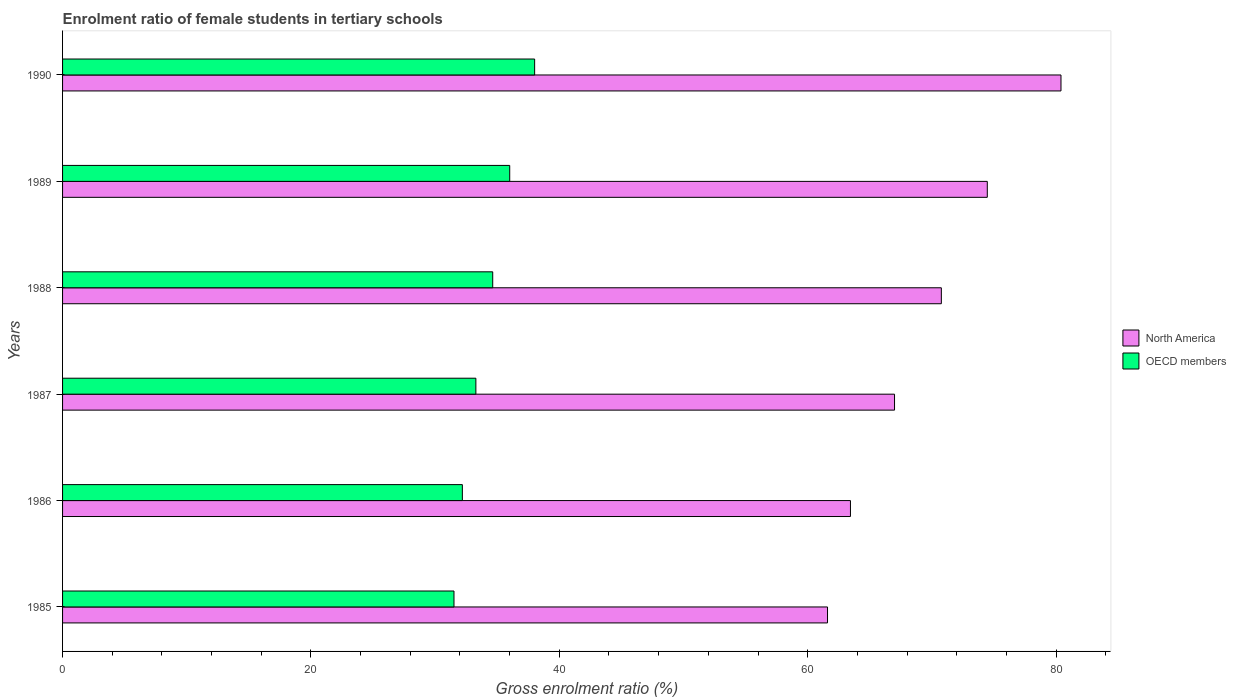How many groups of bars are there?
Your response must be concise. 6. Are the number of bars per tick equal to the number of legend labels?
Ensure brevity in your answer.  Yes. Are the number of bars on each tick of the Y-axis equal?
Offer a very short reply. Yes. How many bars are there on the 1st tick from the top?
Give a very brief answer. 2. How many bars are there on the 2nd tick from the bottom?
Keep it short and to the point. 2. In how many cases, is the number of bars for a given year not equal to the number of legend labels?
Provide a succinct answer. 0. What is the enrolment ratio of female students in tertiary schools in OECD members in 1990?
Ensure brevity in your answer.  38.01. Across all years, what is the maximum enrolment ratio of female students in tertiary schools in North America?
Provide a short and direct response. 80.4. Across all years, what is the minimum enrolment ratio of female students in tertiary schools in OECD members?
Your answer should be very brief. 31.52. In which year was the enrolment ratio of female students in tertiary schools in OECD members maximum?
Make the answer very short. 1990. In which year was the enrolment ratio of female students in tertiary schools in North America minimum?
Offer a terse response. 1985. What is the total enrolment ratio of female students in tertiary schools in North America in the graph?
Give a very brief answer. 417.66. What is the difference between the enrolment ratio of female students in tertiary schools in North America in 1988 and that in 1990?
Your answer should be compact. -9.63. What is the difference between the enrolment ratio of female students in tertiary schools in OECD members in 1990 and the enrolment ratio of female students in tertiary schools in North America in 1988?
Provide a succinct answer. -32.75. What is the average enrolment ratio of female students in tertiary schools in OECD members per year?
Make the answer very short. 34.28. In the year 1987, what is the difference between the enrolment ratio of female students in tertiary schools in OECD members and enrolment ratio of female students in tertiary schools in North America?
Offer a terse response. -33.71. What is the ratio of the enrolment ratio of female students in tertiary schools in North America in 1986 to that in 1988?
Keep it short and to the point. 0.9. Is the difference between the enrolment ratio of female students in tertiary schools in OECD members in 1985 and 1986 greater than the difference between the enrolment ratio of female students in tertiary schools in North America in 1985 and 1986?
Your answer should be compact. Yes. What is the difference between the highest and the second highest enrolment ratio of female students in tertiary schools in North America?
Offer a terse response. 5.93. What is the difference between the highest and the lowest enrolment ratio of female students in tertiary schools in North America?
Offer a terse response. 18.8. Is the sum of the enrolment ratio of female students in tertiary schools in North America in 1985 and 1990 greater than the maximum enrolment ratio of female students in tertiary schools in OECD members across all years?
Keep it short and to the point. Yes. How many bars are there?
Your response must be concise. 12. Are all the bars in the graph horizontal?
Your answer should be very brief. Yes. What is the difference between two consecutive major ticks on the X-axis?
Your answer should be very brief. 20. Are the values on the major ticks of X-axis written in scientific E-notation?
Offer a terse response. No. Does the graph contain any zero values?
Give a very brief answer. No. How many legend labels are there?
Keep it short and to the point. 2. What is the title of the graph?
Offer a terse response. Enrolment ratio of female students in tertiary schools. Does "French Polynesia" appear as one of the legend labels in the graph?
Give a very brief answer. No. What is the label or title of the Y-axis?
Your answer should be very brief. Years. What is the Gross enrolment ratio (%) of North America in 1985?
Your answer should be compact. 61.6. What is the Gross enrolment ratio (%) in OECD members in 1985?
Keep it short and to the point. 31.52. What is the Gross enrolment ratio (%) of North America in 1986?
Give a very brief answer. 63.44. What is the Gross enrolment ratio (%) in OECD members in 1986?
Make the answer very short. 32.19. What is the Gross enrolment ratio (%) in North America in 1987?
Give a very brief answer. 67. What is the Gross enrolment ratio (%) in OECD members in 1987?
Your answer should be compact. 33.28. What is the Gross enrolment ratio (%) of North America in 1988?
Your answer should be compact. 70.76. What is the Gross enrolment ratio (%) of OECD members in 1988?
Your answer should be very brief. 34.64. What is the Gross enrolment ratio (%) of North America in 1989?
Provide a short and direct response. 74.46. What is the Gross enrolment ratio (%) in OECD members in 1989?
Ensure brevity in your answer.  36.01. What is the Gross enrolment ratio (%) of North America in 1990?
Keep it short and to the point. 80.4. What is the Gross enrolment ratio (%) of OECD members in 1990?
Make the answer very short. 38.01. Across all years, what is the maximum Gross enrolment ratio (%) in North America?
Make the answer very short. 80.4. Across all years, what is the maximum Gross enrolment ratio (%) in OECD members?
Your response must be concise. 38.01. Across all years, what is the minimum Gross enrolment ratio (%) in North America?
Your answer should be compact. 61.6. Across all years, what is the minimum Gross enrolment ratio (%) in OECD members?
Make the answer very short. 31.52. What is the total Gross enrolment ratio (%) in North America in the graph?
Provide a short and direct response. 417.66. What is the total Gross enrolment ratio (%) of OECD members in the graph?
Provide a succinct answer. 205.65. What is the difference between the Gross enrolment ratio (%) of North America in 1985 and that in 1986?
Offer a terse response. -1.85. What is the difference between the Gross enrolment ratio (%) in OECD members in 1985 and that in 1986?
Offer a terse response. -0.67. What is the difference between the Gross enrolment ratio (%) in North America in 1985 and that in 1987?
Offer a very short reply. -5.4. What is the difference between the Gross enrolment ratio (%) of OECD members in 1985 and that in 1987?
Your response must be concise. -1.76. What is the difference between the Gross enrolment ratio (%) of North America in 1985 and that in 1988?
Offer a terse response. -9.17. What is the difference between the Gross enrolment ratio (%) of OECD members in 1985 and that in 1988?
Offer a terse response. -3.12. What is the difference between the Gross enrolment ratio (%) of North America in 1985 and that in 1989?
Give a very brief answer. -12.87. What is the difference between the Gross enrolment ratio (%) of OECD members in 1985 and that in 1989?
Keep it short and to the point. -4.49. What is the difference between the Gross enrolment ratio (%) of North America in 1985 and that in 1990?
Ensure brevity in your answer.  -18.8. What is the difference between the Gross enrolment ratio (%) of OECD members in 1985 and that in 1990?
Offer a terse response. -6.49. What is the difference between the Gross enrolment ratio (%) in North America in 1986 and that in 1987?
Make the answer very short. -3.55. What is the difference between the Gross enrolment ratio (%) in OECD members in 1986 and that in 1987?
Your answer should be very brief. -1.09. What is the difference between the Gross enrolment ratio (%) of North America in 1986 and that in 1988?
Keep it short and to the point. -7.32. What is the difference between the Gross enrolment ratio (%) in OECD members in 1986 and that in 1988?
Keep it short and to the point. -2.44. What is the difference between the Gross enrolment ratio (%) in North America in 1986 and that in 1989?
Your answer should be compact. -11.02. What is the difference between the Gross enrolment ratio (%) in OECD members in 1986 and that in 1989?
Ensure brevity in your answer.  -3.81. What is the difference between the Gross enrolment ratio (%) of North America in 1986 and that in 1990?
Ensure brevity in your answer.  -16.95. What is the difference between the Gross enrolment ratio (%) in OECD members in 1986 and that in 1990?
Make the answer very short. -5.82. What is the difference between the Gross enrolment ratio (%) of North America in 1987 and that in 1988?
Keep it short and to the point. -3.77. What is the difference between the Gross enrolment ratio (%) of OECD members in 1987 and that in 1988?
Provide a short and direct response. -1.36. What is the difference between the Gross enrolment ratio (%) in North America in 1987 and that in 1989?
Your answer should be very brief. -7.47. What is the difference between the Gross enrolment ratio (%) of OECD members in 1987 and that in 1989?
Your answer should be compact. -2.73. What is the difference between the Gross enrolment ratio (%) of North America in 1987 and that in 1990?
Your answer should be very brief. -13.4. What is the difference between the Gross enrolment ratio (%) in OECD members in 1987 and that in 1990?
Give a very brief answer. -4.73. What is the difference between the Gross enrolment ratio (%) in North America in 1988 and that in 1989?
Make the answer very short. -3.7. What is the difference between the Gross enrolment ratio (%) of OECD members in 1988 and that in 1989?
Make the answer very short. -1.37. What is the difference between the Gross enrolment ratio (%) in North America in 1988 and that in 1990?
Your answer should be very brief. -9.63. What is the difference between the Gross enrolment ratio (%) of OECD members in 1988 and that in 1990?
Make the answer very short. -3.38. What is the difference between the Gross enrolment ratio (%) of North America in 1989 and that in 1990?
Offer a terse response. -5.93. What is the difference between the Gross enrolment ratio (%) in OECD members in 1989 and that in 1990?
Provide a short and direct response. -2.01. What is the difference between the Gross enrolment ratio (%) of North America in 1985 and the Gross enrolment ratio (%) of OECD members in 1986?
Your answer should be compact. 29.4. What is the difference between the Gross enrolment ratio (%) of North America in 1985 and the Gross enrolment ratio (%) of OECD members in 1987?
Make the answer very short. 28.32. What is the difference between the Gross enrolment ratio (%) in North America in 1985 and the Gross enrolment ratio (%) in OECD members in 1988?
Your response must be concise. 26.96. What is the difference between the Gross enrolment ratio (%) in North America in 1985 and the Gross enrolment ratio (%) in OECD members in 1989?
Your answer should be compact. 25.59. What is the difference between the Gross enrolment ratio (%) of North America in 1985 and the Gross enrolment ratio (%) of OECD members in 1990?
Provide a short and direct response. 23.58. What is the difference between the Gross enrolment ratio (%) of North America in 1986 and the Gross enrolment ratio (%) of OECD members in 1987?
Provide a short and direct response. 30.16. What is the difference between the Gross enrolment ratio (%) of North America in 1986 and the Gross enrolment ratio (%) of OECD members in 1988?
Your response must be concise. 28.81. What is the difference between the Gross enrolment ratio (%) in North America in 1986 and the Gross enrolment ratio (%) in OECD members in 1989?
Your answer should be compact. 27.44. What is the difference between the Gross enrolment ratio (%) of North America in 1986 and the Gross enrolment ratio (%) of OECD members in 1990?
Offer a very short reply. 25.43. What is the difference between the Gross enrolment ratio (%) of North America in 1987 and the Gross enrolment ratio (%) of OECD members in 1988?
Your answer should be compact. 32.36. What is the difference between the Gross enrolment ratio (%) in North America in 1987 and the Gross enrolment ratio (%) in OECD members in 1989?
Ensure brevity in your answer.  30.99. What is the difference between the Gross enrolment ratio (%) of North America in 1987 and the Gross enrolment ratio (%) of OECD members in 1990?
Provide a succinct answer. 28.98. What is the difference between the Gross enrolment ratio (%) in North America in 1988 and the Gross enrolment ratio (%) in OECD members in 1989?
Ensure brevity in your answer.  34.76. What is the difference between the Gross enrolment ratio (%) of North America in 1988 and the Gross enrolment ratio (%) of OECD members in 1990?
Your response must be concise. 32.75. What is the difference between the Gross enrolment ratio (%) of North America in 1989 and the Gross enrolment ratio (%) of OECD members in 1990?
Your answer should be very brief. 36.45. What is the average Gross enrolment ratio (%) in North America per year?
Offer a terse response. 69.61. What is the average Gross enrolment ratio (%) in OECD members per year?
Provide a succinct answer. 34.28. In the year 1985, what is the difference between the Gross enrolment ratio (%) in North America and Gross enrolment ratio (%) in OECD members?
Your answer should be compact. 30.08. In the year 1986, what is the difference between the Gross enrolment ratio (%) of North America and Gross enrolment ratio (%) of OECD members?
Keep it short and to the point. 31.25. In the year 1987, what is the difference between the Gross enrolment ratio (%) in North America and Gross enrolment ratio (%) in OECD members?
Give a very brief answer. 33.71. In the year 1988, what is the difference between the Gross enrolment ratio (%) of North America and Gross enrolment ratio (%) of OECD members?
Give a very brief answer. 36.13. In the year 1989, what is the difference between the Gross enrolment ratio (%) in North America and Gross enrolment ratio (%) in OECD members?
Your answer should be very brief. 38.46. In the year 1990, what is the difference between the Gross enrolment ratio (%) in North America and Gross enrolment ratio (%) in OECD members?
Ensure brevity in your answer.  42.38. What is the ratio of the Gross enrolment ratio (%) in North America in 1985 to that in 1986?
Make the answer very short. 0.97. What is the ratio of the Gross enrolment ratio (%) of OECD members in 1985 to that in 1986?
Keep it short and to the point. 0.98. What is the ratio of the Gross enrolment ratio (%) in North America in 1985 to that in 1987?
Your answer should be compact. 0.92. What is the ratio of the Gross enrolment ratio (%) in OECD members in 1985 to that in 1987?
Ensure brevity in your answer.  0.95. What is the ratio of the Gross enrolment ratio (%) of North America in 1985 to that in 1988?
Provide a succinct answer. 0.87. What is the ratio of the Gross enrolment ratio (%) of OECD members in 1985 to that in 1988?
Give a very brief answer. 0.91. What is the ratio of the Gross enrolment ratio (%) in North America in 1985 to that in 1989?
Keep it short and to the point. 0.83. What is the ratio of the Gross enrolment ratio (%) of OECD members in 1985 to that in 1989?
Keep it short and to the point. 0.88. What is the ratio of the Gross enrolment ratio (%) in North America in 1985 to that in 1990?
Keep it short and to the point. 0.77. What is the ratio of the Gross enrolment ratio (%) of OECD members in 1985 to that in 1990?
Make the answer very short. 0.83. What is the ratio of the Gross enrolment ratio (%) in North America in 1986 to that in 1987?
Give a very brief answer. 0.95. What is the ratio of the Gross enrolment ratio (%) of OECD members in 1986 to that in 1987?
Offer a terse response. 0.97. What is the ratio of the Gross enrolment ratio (%) in North America in 1986 to that in 1988?
Offer a terse response. 0.9. What is the ratio of the Gross enrolment ratio (%) of OECD members in 1986 to that in 1988?
Offer a terse response. 0.93. What is the ratio of the Gross enrolment ratio (%) of North America in 1986 to that in 1989?
Provide a succinct answer. 0.85. What is the ratio of the Gross enrolment ratio (%) of OECD members in 1986 to that in 1989?
Offer a terse response. 0.89. What is the ratio of the Gross enrolment ratio (%) in North America in 1986 to that in 1990?
Offer a very short reply. 0.79. What is the ratio of the Gross enrolment ratio (%) of OECD members in 1986 to that in 1990?
Your answer should be compact. 0.85. What is the ratio of the Gross enrolment ratio (%) of North America in 1987 to that in 1988?
Give a very brief answer. 0.95. What is the ratio of the Gross enrolment ratio (%) in OECD members in 1987 to that in 1988?
Your answer should be compact. 0.96. What is the ratio of the Gross enrolment ratio (%) of North America in 1987 to that in 1989?
Offer a terse response. 0.9. What is the ratio of the Gross enrolment ratio (%) of OECD members in 1987 to that in 1989?
Offer a very short reply. 0.92. What is the ratio of the Gross enrolment ratio (%) in OECD members in 1987 to that in 1990?
Your response must be concise. 0.88. What is the ratio of the Gross enrolment ratio (%) in North America in 1988 to that in 1989?
Keep it short and to the point. 0.95. What is the ratio of the Gross enrolment ratio (%) of OECD members in 1988 to that in 1989?
Offer a very short reply. 0.96. What is the ratio of the Gross enrolment ratio (%) in North America in 1988 to that in 1990?
Make the answer very short. 0.88. What is the ratio of the Gross enrolment ratio (%) in OECD members in 1988 to that in 1990?
Your response must be concise. 0.91. What is the ratio of the Gross enrolment ratio (%) in North America in 1989 to that in 1990?
Provide a short and direct response. 0.93. What is the ratio of the Gross enrolment ratio (%) of OECD members in 1989 to that in 1990?
Keep it short and to the point. 0.95. What is the difference between the highest and the second highest Gross enrolment ratio (%) of North America?
Offer a very short reply. 5.93. What is the difference between the highest and the second highest Gross enrolment ratio (%) of OECD members?
Make the answer very short. 2.01. What is the difference between the highest and the lowest Gross enrolment ratio (%) in North America?
Keep it short and to the point. 18.8. What is the difference between the highest and the lowest Gross enrolment ratio (%) in OECD members?
Provide a short and direct response. 6.49. 